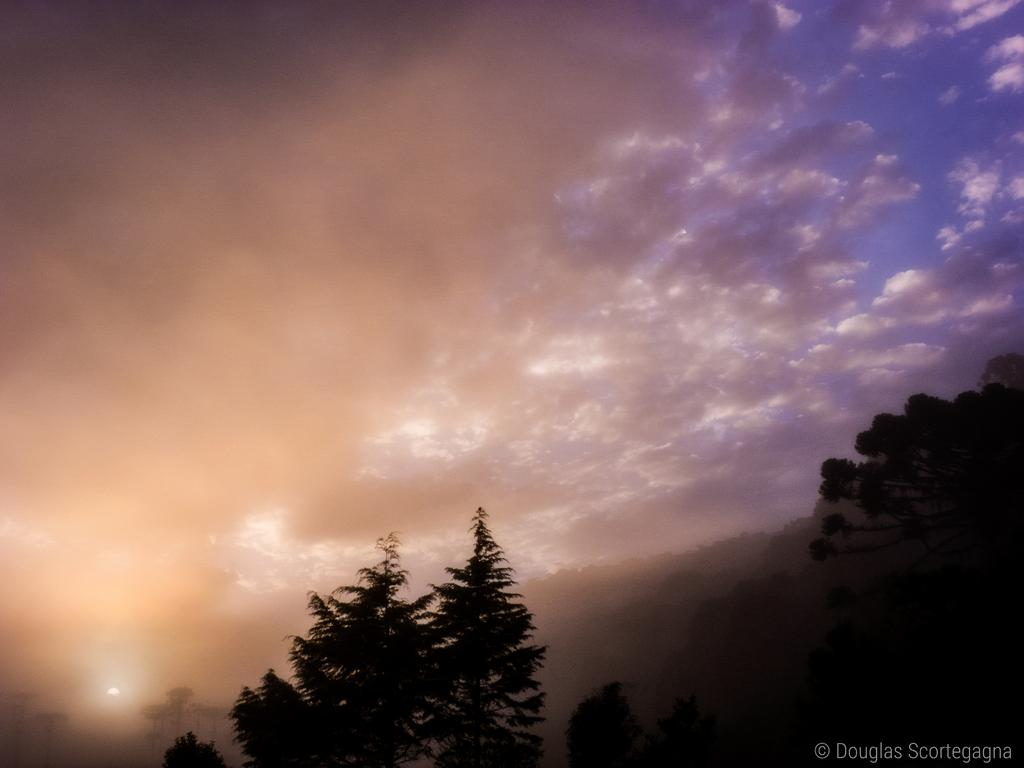What type of view is shown in the image? The image is an outside view. What can be seen at the bottom of the image? There are trees at the bottom of the image. What is visible at the top of the image? The sky is visible at the top of the image. What can be observed in the sky? Clouds are present in the sky. Where is the text located in the image? The text is on the right bottom of the image. What type of animals can be seen in the zoo in the image? There is no zoo present in the image, so it is not possible to determine what animals might be seen. 